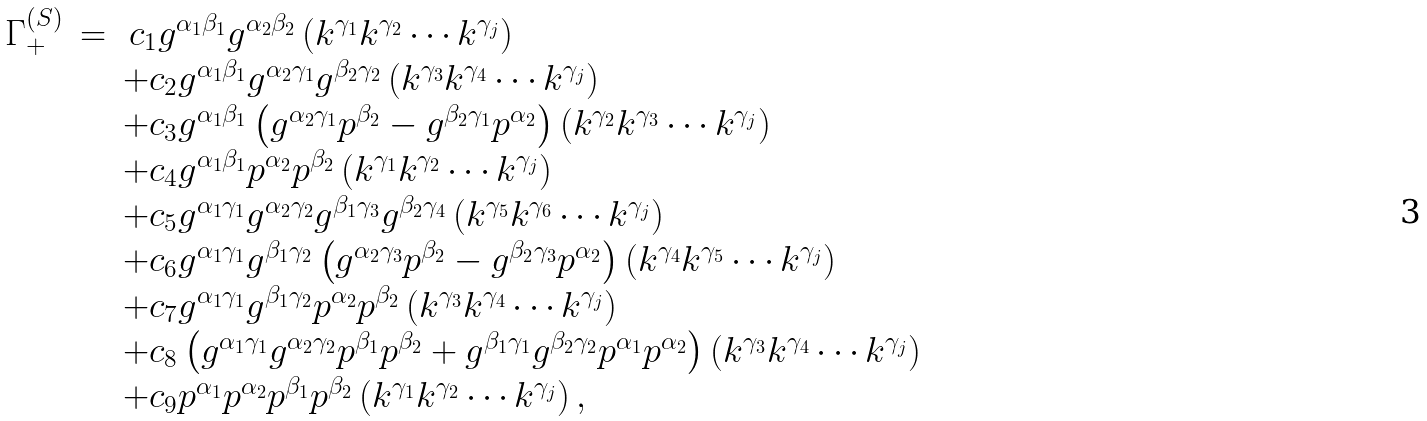Convert formula to latex. <formula><loc_0><loc_0><loc_500><loc_500>\begin{array} { r c l } \Gamma _ { + } ^ { ( S ) } & = & \, c _ { 1 } g ^ { \alpha _ { 1 } \beta _ { 1 } } g ^ { \alpha _ { 2 } \beta _ { 2 } } \left ( k ^ { \gamma _ { 1 } } k ^ { \gamma _ { 2 } } \cdots k ^ { \gamma _ { j } } \right ) \\ & & + c _ { 2 } g ^ { \alpha _ { 1 } \beta _ { 1 } } g ^ { \alpha _ { 2 } \gamma _ { 1 } } g ^ { \beta _ { 2 } \gamma _ { 2 } } \left ( k ^ { \gamma _ { 3 } } k ^ { \gamma _ { 4 } } \cdots k ^ { \gamma _ { j } } \right ) \\ & & + c _ { 3 } g ^ { \alpha _ { 1 } \beta _ { 1 } } \left ( g ^ { \alpha _ { 2 } \gamma _ { 1 } } p ^ { \beta _ { 2 } } - g ^ { \beta _ { 2 } \gamma _ { 1 } } p ^ { \alpha _ { 2 } } \right ) \left ( k ^ { \gamma _ { 2 } } k ^ { \gamma _ { 3 } } \cdots k ^ { \gamma _ { j } } \right ) \\ & & + c _ { 4 } g ^ { \alpha _ { 1 } \beta _ { 1 } } p ^ { \alpha _ { 2 } } p ^ { \beta _ { 2 } } \left ( k ^ { \gamma _ { 1 } } k ^ { \gamma _ { 2 } } \cdots k ^ { \gamma _ { j } } \right ) \\ & & + c _ { 5 } g ^ { \alpha _ { 1 } \gamma _ { 1 } } g ^ { \alpha _ { 2 } \gamma _ { 2 } } g ^ { \beta _ { 1 } \gamma _ { 3 } } g ^ { \beta _ { 2 } \gamma _ { 4 } } \left ( k ^ { \gamma _ { 5 } } k ^ { \gamma _ { 6 } } \cdots k ^ { \gamma _ { j } } \right ) \\ & & + c _ { 6 } g ^ { \alpha _ { 1 } \gamma _ { 1 } } g ^ { \beta _ { 1 } \gamma _ { 2 } } \left ( g ^ { \alpha _ { 2 } \gamma _ { 3 } } p ^ { \beta _ { 2 } } - g ^ { \beta _ { 2 } \gamma _ { 3 } } p ^ { \alpha _ { 2 } } \right ) \left ( k ^ { \gamma _ { 4 } } k ^ { \gamma _ { 5 } } \cdots k ^ { \gamma _ { j } } \right ) \\ & & + c _ { 7 } g ^ { \alpha _ { 1 } \gamma _ { 1 } } g ^ { \beta _ { 1 } \gamma _ { 2 } } p ^ { \alpha _ { 2 } } p ^ { \beta _ { 2 } } \left ( k ^ { \gamma _ { 3 } } k ^ { \gamma _ { 4 } } \cdots k ^ { \gamma _ { j } } \right ) \\ & & + c _ { 8 } \left ( g ^ { \alpha _ { 1 } \gamma _ { 1 } } g ^ { \alpha _ { 2 } \gamma _ { 2 } } p ^ { \beta _ { 1 } } p ^ { \beta _ { 2 } } + g ^ { \beta _ { 1 } \gamma _ { 1 } } g ^ { \beta _ { 2 } \gamma _ { 2 } } p ^ { \alpha _ { 1 } } p ^ { \alpha _ { 2 } } \right ) \left ( k ^ { \gamma _ { 3 } } k ^ { \gamma _ { 4 } } \cdots k ^ { \gamma _ { j } } \right ) \\ & & + c _ { 9 } p ^ { \alpha _ { 1 } } p ^ { \alpha _ { 2 } } p ^ { \beta _ { 1 } } p ^ { \beta _ { 2 } } \left ( k ^ { \gamma _ { 1 } } k ^ { \gamma _ { 2 } } \cdots k ^ { \gamma _ { j } } \right ) , \end{array}</formula> 